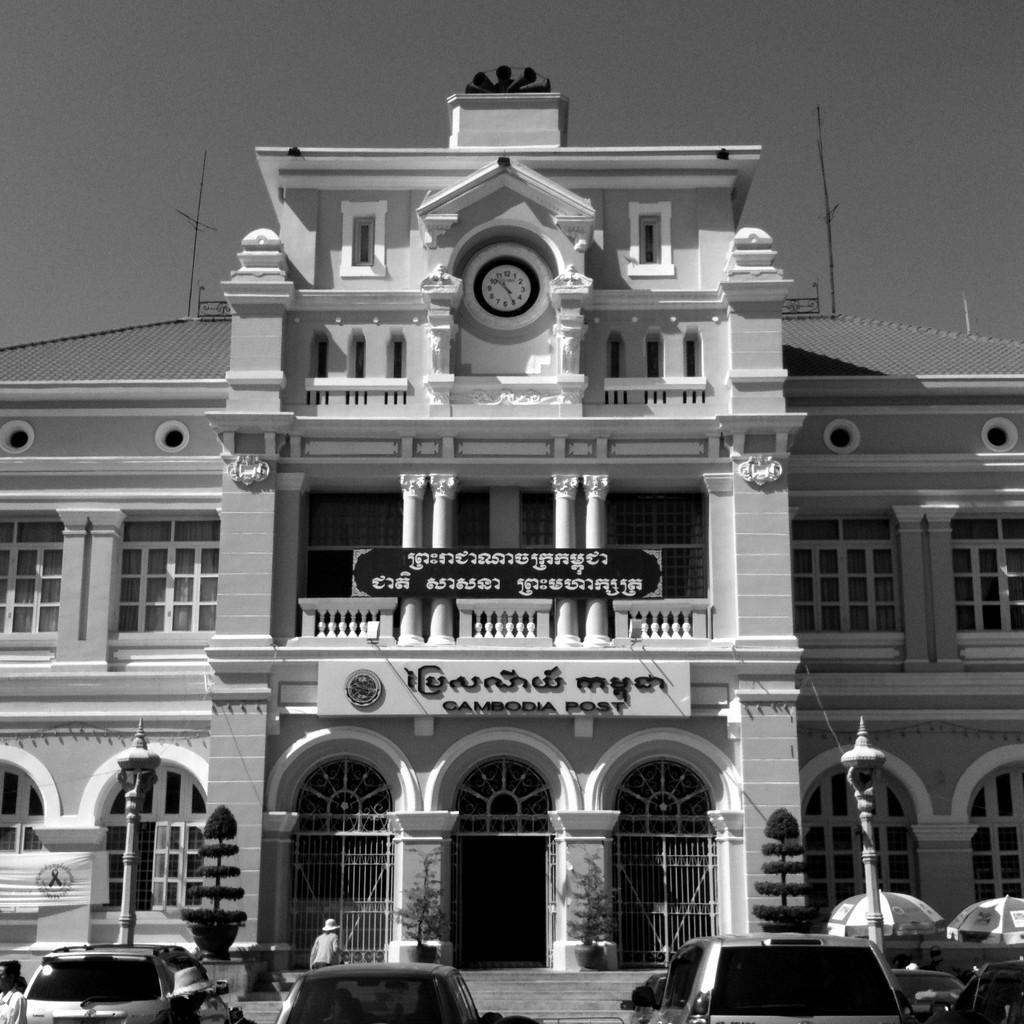What is the color scheme of the image? The image is black and white. What can be seen at the bottom of the image? There are cars and poles at the bottom of the image. What structure is located in the middle of the image? There is a building in the middle of the image. What is visible at the top of the image? The sky is visible at the top of the image. What type of mitten is being used to process the recess in the image? There is no mitten or recess present in the image; it features a black and white scene with cars, poles, a building, and the sky. 